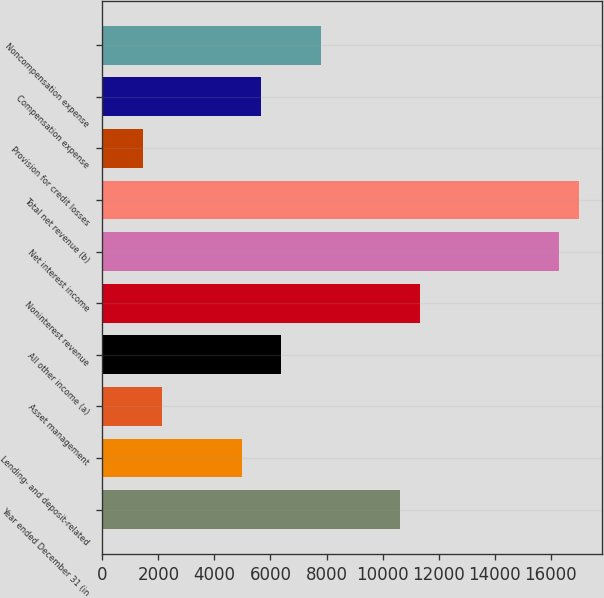<chart> <loc_0><loc_0><loc_500><loc_500><bar_chart><fcel>Year ended December 31 (in<fcel>Lending- and deposit-related<fcel>Asset management<fcel>All other income (a)<fcel>Noninterest revenue<fcel>Net interest income<fcel>Total net revenue (b)<fcel>Provision for credit losses<fcel>Compensation expense<fcel>Noncompensation expense<nl><fcel>10628.5<fcel>4970.1<fcel>2140.9<fcel>6384.7<fcel>11335.8<fcel>16286.9<fcel>16994.2<fcel>1433.6<fcel>5677.4<fcel>7799.3<nl></chart> 